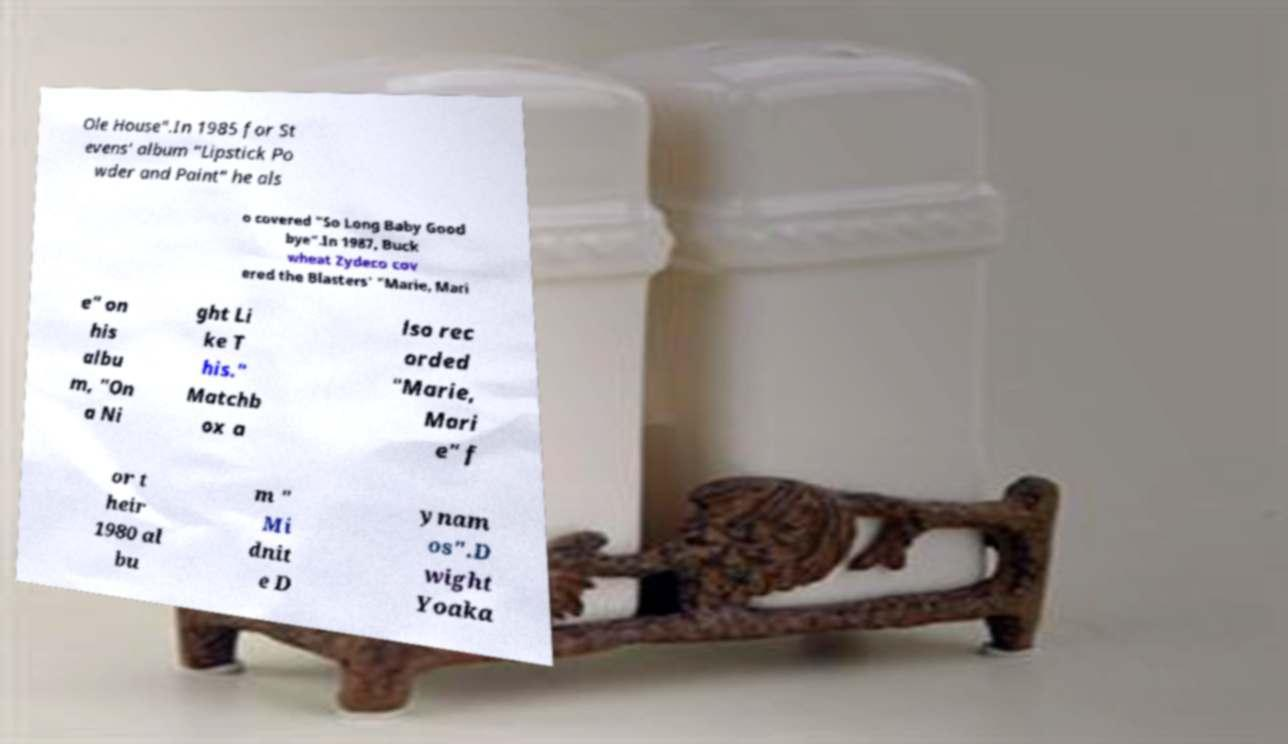Can you read and provide the text displayed in the image?This photo seems to have some interesting text. Can you extract and type it out for me? Ole House".In 1985 for St evens' album "Lipstick Po wder and Paint" he als o covered "So Long Baby Good bye".In 1987, Buck wheat Zydeco cov ered the Blasters' "Marie, Mari e" on his albu m, "On a Ni ght Li ke T his." Matchb ox a lso rec orded "Marie, Mari e" f or t heir 1980 al bu m " Mi dnit e D ynam os".D wight Yoaka 